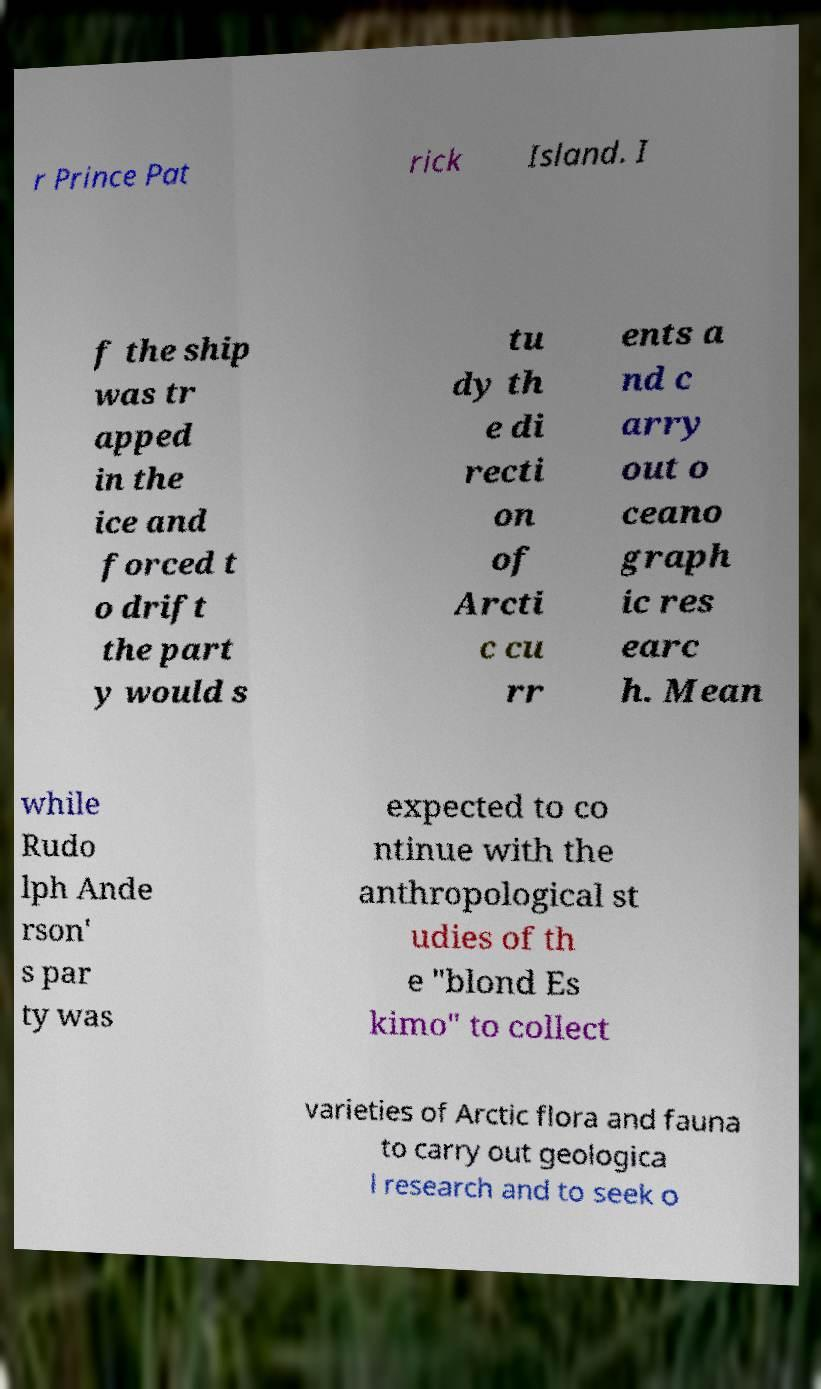For documentation purposes, I need the text within this image transcribed. Could you provide that? r Prince Pat rick Island. I f the ship was tr apped in the ice and forced t o drift the part y would s tu dy th e di recti on of Arcti c cu rr ents a nd c arry out o ceano graph ic res earc h. Mean while Rudo lph Ande rson' s par ty was expected to co ntinue with the anthropological st udies of th e "blond Es kimo" to collect varieties of Arctic flora and fauna to carry out geologica l research and to seek o 